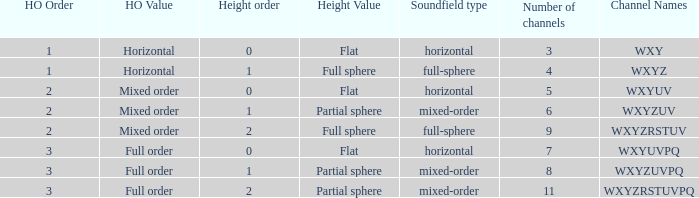If the channels is wxyzrstuvpq, what is the horizontal order? 3.0. 